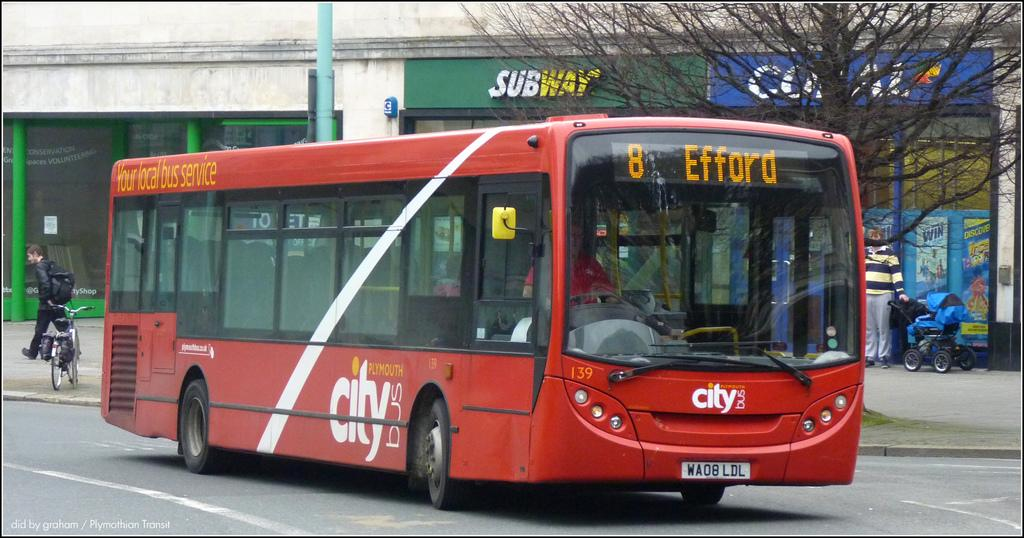<image>
Offer a succinct explanation of the picture presented. A large, red city bus for Efford with 'Your local bus service' on its side. 